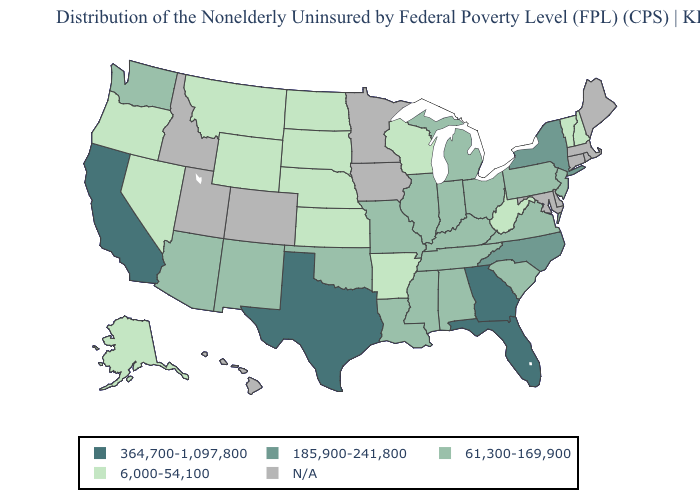Name the states that have a value in the range N/A?
Answer briefly. Colorado, Connecticut, Delaware, Hawaii, Idaho, Iowa, Maine, Maryland, Massachusetts, Minnesota, Rhode Island, Utah. Which states have the lowest value in the USA?
Answer briefly. Alaska, Arkansas, Kansas, Montana, Nebraska, Nevada, New Hampshire, North Dakota, Oregon, South Dakota, Vermont, West Virginia, Wisconsin, Wyoming. What is the highest value in states that border Nebraska?
Give a very brief answer. 61,300-169,900. How many symbols are there in the legend?
Quick response, please. 5. Does New Hampshire have the lowest value in the USA?
Keep it brief. Yes. Does the first symbol in the legend represent the smallest category?
Short answer required. No. Among the states that border Maine , which have the highest value?
Keep it brief. New Hampshire. What is the lowest value in the MidWest?
Answer briefly. 6,000-54,100. Among the states that border Vermont , does New Hampshire have the lowest value?
Write a very short answer. Yes. Does North Dakota have the lowest value in the MidWest?
Short answer required. Yes. What is the value of Ohio?
Short answer required. 61,300-169,900. Name the states that have a value in the range 61,300-169,900?
Be succinct. Alabama, Arizona, Illinois, Indiana, Kentucky, Louisiana, Michigan, Mississippi, Missouri, New Jersey, New Mexico, Ohio, Oklahoma, Pennsylvania, South Carolina, Tennessee, Virginia, Washington. Name the states that have a value in the range 364,700-1,097,800?
Give a very brief answer. California, Florida, Georgia, Texas. Does Nebraska have the lowest value in the USA?
Concise answer only. Yes. Does the first symbol in the legend represent the smallest category?
Short answer required. No. 